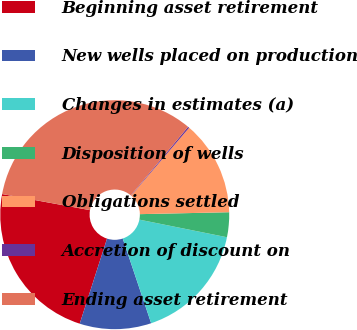<chart> <loc_0><loc_0><loc_500><loc_500><pie_chart><fcel>Beginning asset retirement<fcel>New wells placed on production<fcel>Changes in estimates (a)<fcel>Disposition of wells<fcel>Obligations settled<fcel>Accretion of discount on<fcel>Ending asset retirement<nl><fcel>22.94%<fcel>10.1%<fcel>16.69%<fcel>3.5%<fcel>13.39%<fcel>0.2%<fcel>33.18%<nl></chart> 